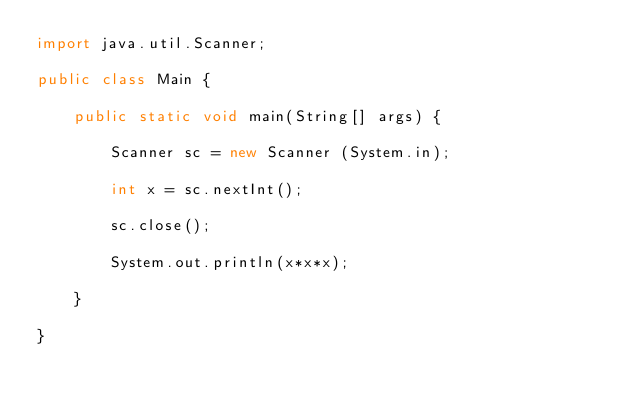Convert code to text. <code><loc_0><loc_0><loc_500><loc_500><_Java_>import java.util.Scanner;

public class Main {

	public static void main(String[] args) {

		Scanner sc = new Scanner (System.in);
		
		int x = sc.nextInt();
		
		sc.close();
		
		System.out.println(x*x*x);
		
	}

}</code> 